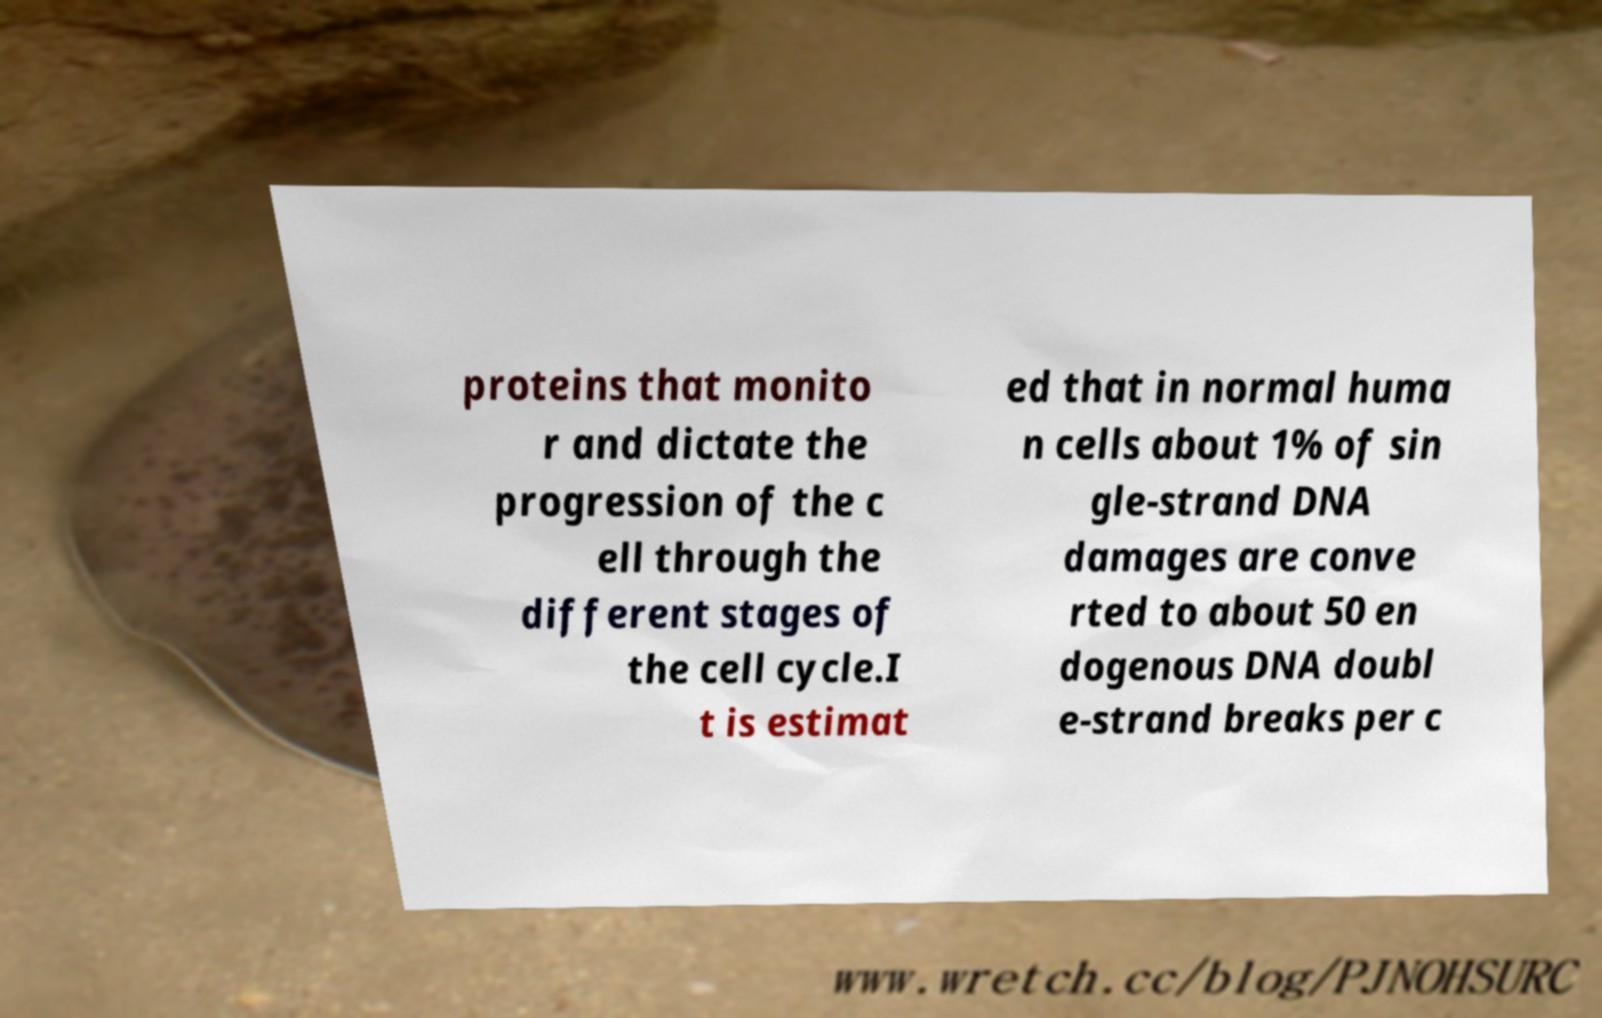For documentation purposes, I need the text within this image transcribed. Could you provide that? proteins that monito r and dictate the progression of the c ell through the different stages of the cell cycle.I t is estimat ed that in normal huma n cells about 1% of sin gle-strand DNA damages are conve rted to about 50 en dogenous DNA doubl e-strand breaks per c 